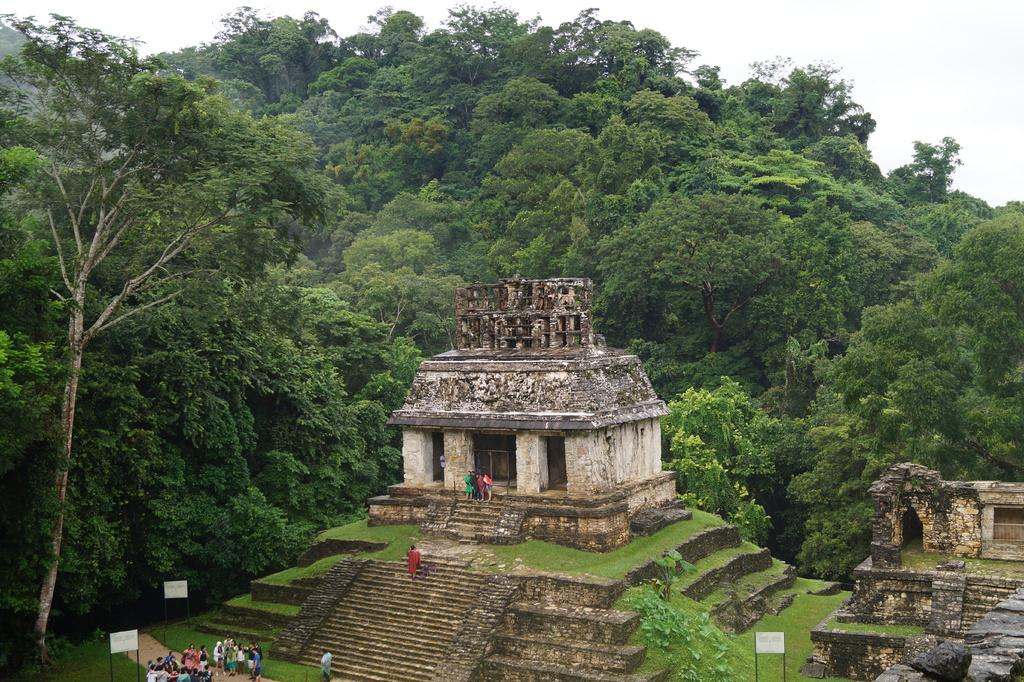What types of locations are depicted in the image? There are places in the image. Who or what can be seen in the image? There are people in the image. What objects are present in the image? There are boards in the image. What type of natural environment is visible in the image? There is grass, plants, and trees in the image. What part of the natural environment is visible in the background of the image? The sky is visible in the background of the image. What type of knot is being tied by the people in the image? There is no knot-tying activity depicted in the image. What answers are being given by the people in the image? There is no indication of any answers being given in the image. 